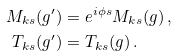Convert formula to latex. <formula><loc_0><loc_0><loc_500><loc_500>M _ { k s } ( g ^ { \prime } ) & = e ^ { i \phi s } M _ { k s } ( g ) \, , \\ T _ { k s } ( g ^ { \prime } ) & = T _ { k s } ( g ) \, .</formula> 